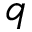Convert formula to latex. <formula><loc_0><loc_0><loc_500><loc_500>q</formula> 